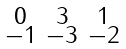<formula> <loc_0><loc_0><loc_500><loc_500>\begin{smallmatrix} 0 & 3 & 1 \\ - 1 & - 3 & - 2 \end{smallmatrix}</formula> 